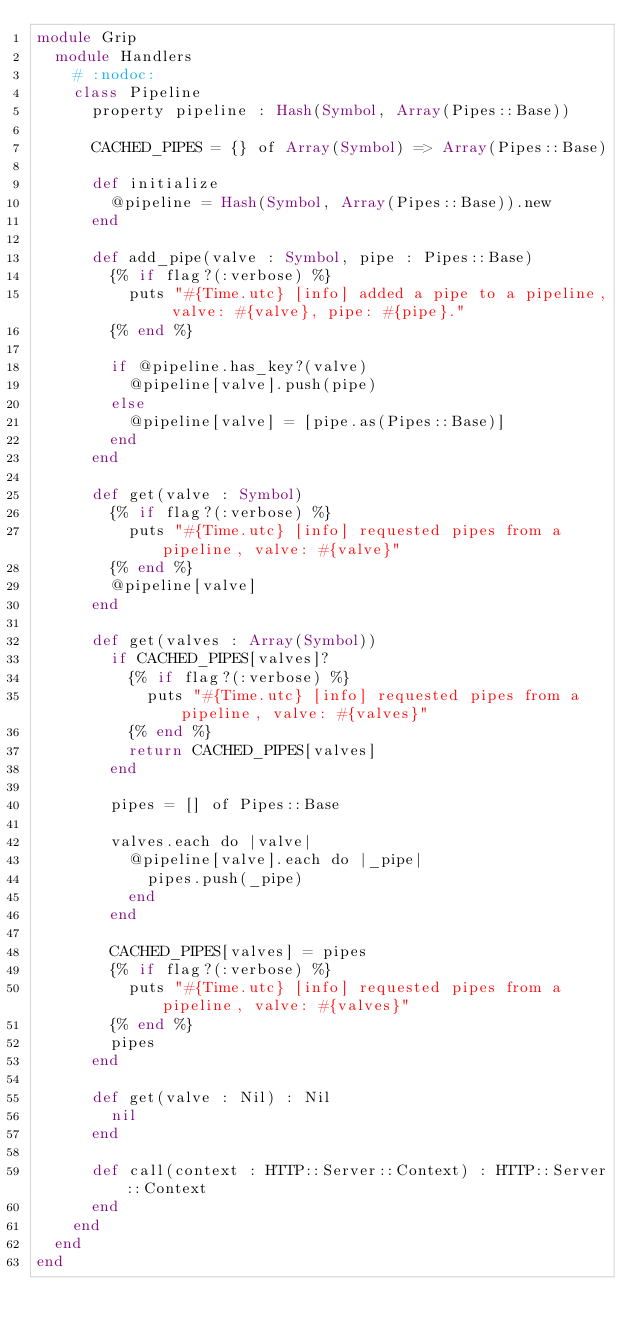<code> <loc_0><loc_0><loc_500><loc_500><_Crystal_>module Grip
  module Handlers
    # :nodoc:
    class Pipeline
      property pipeline : Hash(Symbol, Array(Pipes::Base))

      CACHED_PIPES = {} of Array(Symbol) => Array(Pipes::Base)

      def initialize
        @pipeline = Hash(Symbol, Array(Pipes::Base)).new
      end

      def add_pipe(valve : Symbol, pipe : Pipes::Base)
        {% if flag?(:verbose) %}
          puts "#{Time.utc} [info] added a pipe to a pipeline, valve: #{valve}, pipe: #{pipe}."
        {% end %}

        if @pipeline.has_key?(valve)
          @pipeline[valve].push(pipe)
        else
          @pipeline[valve] = [pipe.as(Pipes::Base)]
        end
      end

      def get(valve : Symbol)
        {% if flag?(:verbose) %}
          puts "#{Time.utc} [info] requested pipes from a pipeline, valve: #{valve}"
        {% end %}
        @pipeline[valve]
      end

      def get(valves : Array(Symbol))
        if CACHED_PIPES[valves]?
          {% if flag?(:verbose) %}
            puts "#{Time.utc} [info] requested pipes from a pipeline, valve: #{valves}"
          {% end %}
          return CACHED_PIPES[valves]
        end

        pipes = [] of Pipes::Base

        valves.each do |valve|
          @pipeline[valve].each do |_pipe|
            pipes.push(_pipe)
          end
        end

        CACHED_PIPES[valves] = pipes
        {% if flag?(:verbose) %}
          puts "#{Time.utc} [info] requested pipes from a pipeline, valve: #{valves}"
        {% end %}
        pipes
      end

      def get(valve : Nil) : Nil
        nil
      end

      def call(context : HTTP::Server::Context) : HTTP::Server::Context
      end
    end
  end
end
</code> 